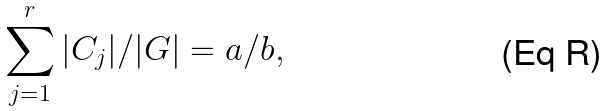Convert formula to latex. <formula><loc_0><loc_0><loc_500><loc_500>\sum _ { j = 1 } ^ { r } | C _ { j } | / | G | = a / b ,</formula> 